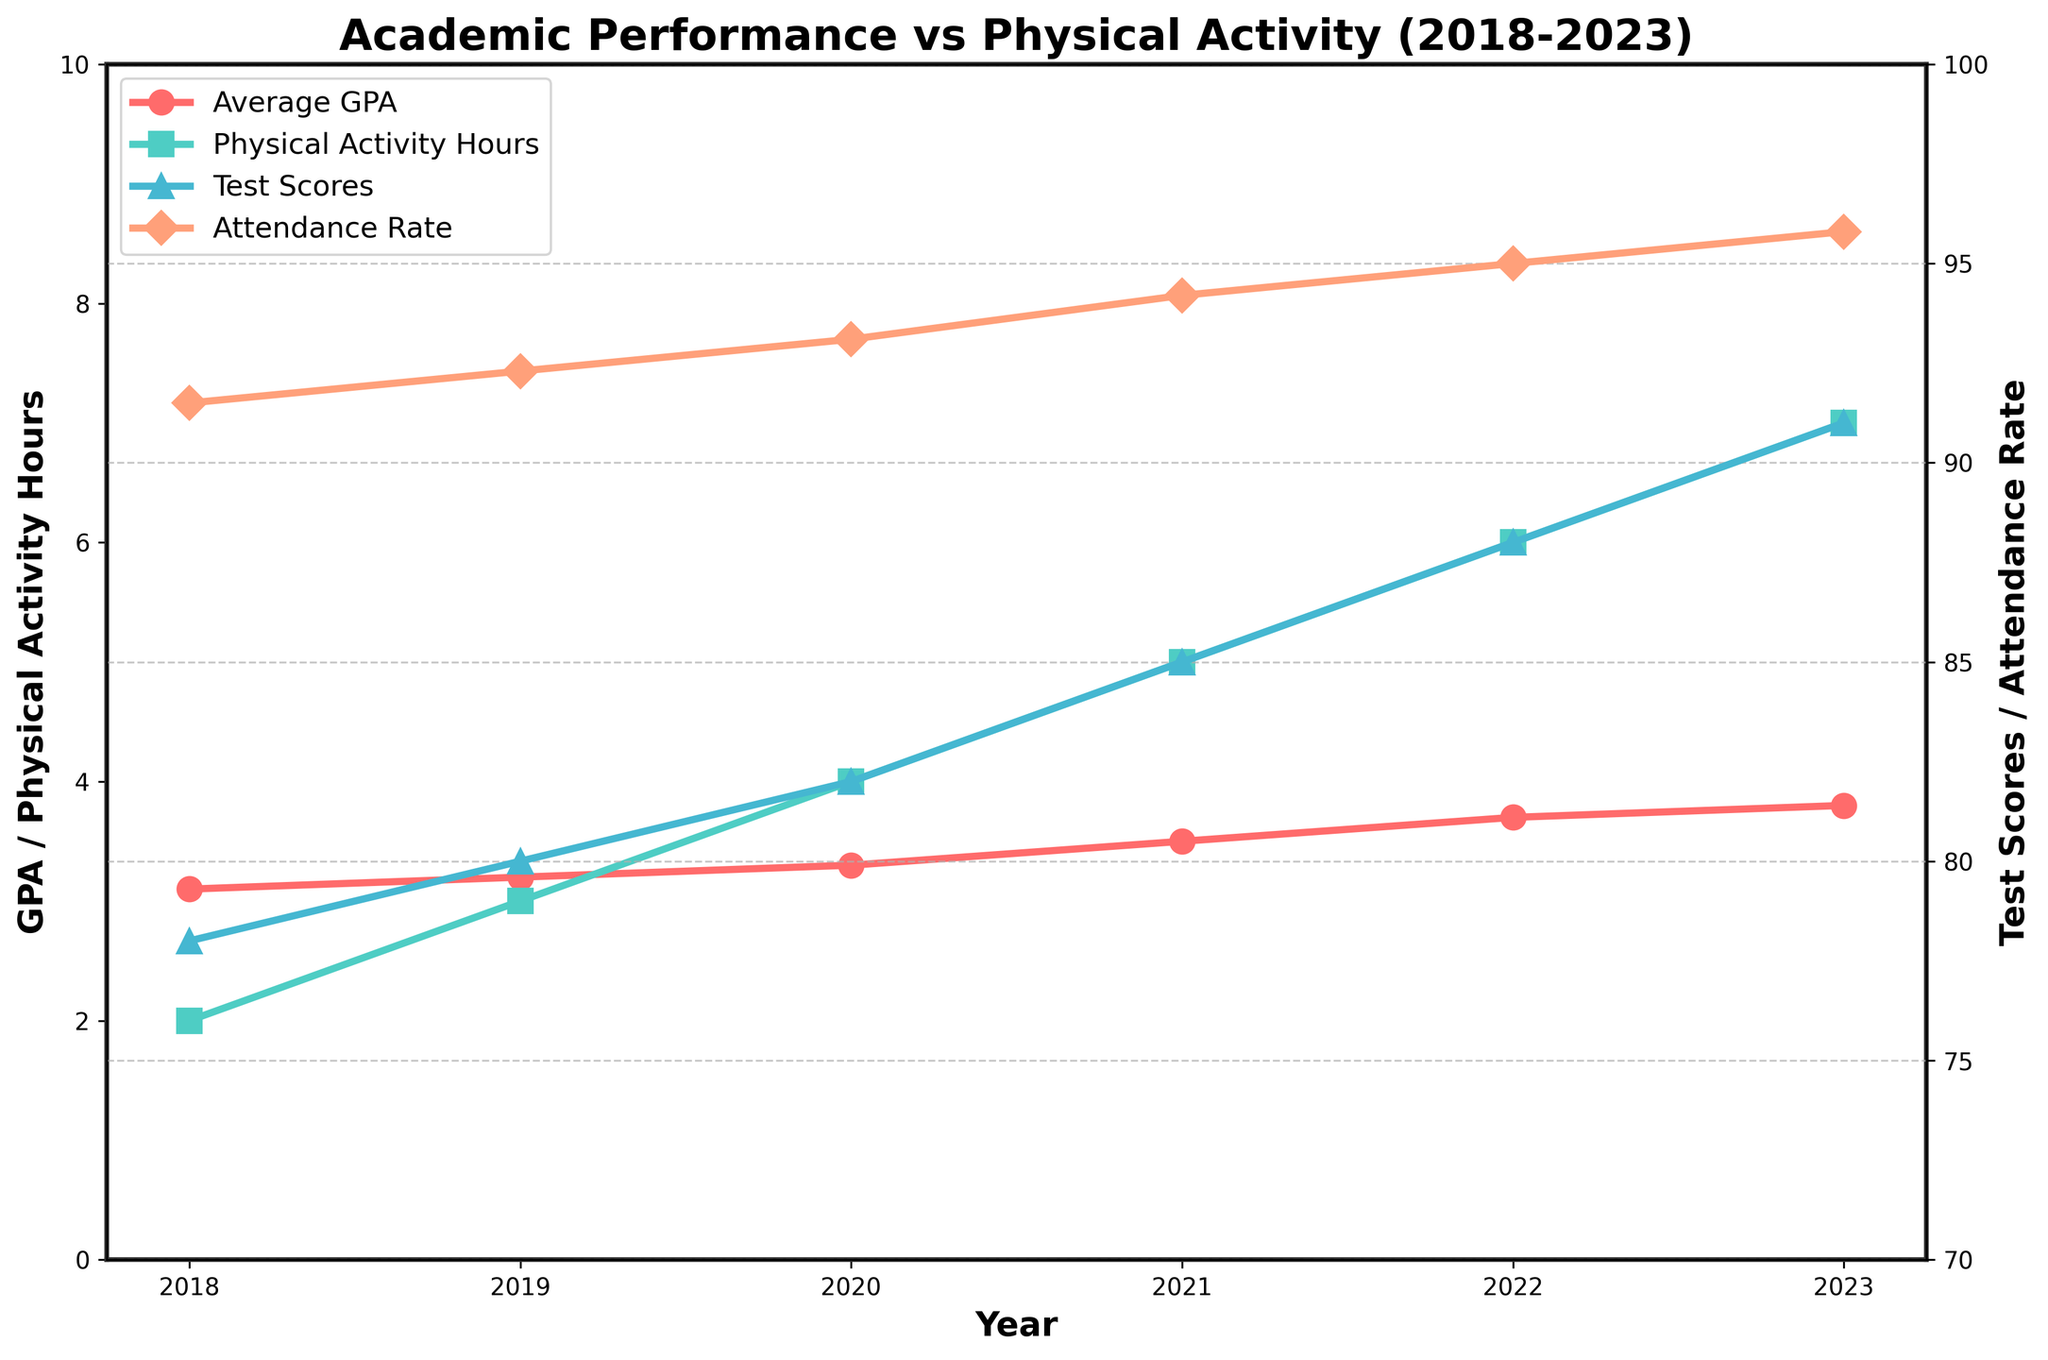What trend do you observe in the Average GPA from 2018 to 2023? Observe the red line with circle markers. It starts at 3.1 in 2018 and increases steadily each year until it reaches 3.8 in 2023.
Answer: It is increasing By how much did the Physical Activity Hours per Week increase from 2018 to 2023? Observe the green line with square markers. In 2018, it is 2 hours per week, and in 2023, it is 7 hours per week. The increase is 7 - 2 = 5 hours.
Answer: 5 hours In which year did the Standardized Test Scores see the largest increase from the previous year? Observe the blue line with triangle markers. Calculate the year-to-year differences: 2018 to 2019 (+2), 2019 to 2020 (+2), 2020 to 2021 (+3), 2021 to 2022 (+3), 2022 to 2023 (+3). The largest increase is 3, which occurred from 2020 to 2021, 2021 to 2022, and 2022 to 2023.
Answer: 2020 to 2021, 2021 to 2022, 2022 to 2023 What is the average Student Attendance Rate over the years 2018 to 2023? Calculate the sum and then the average: (91.5 + 92.3 + 93.1 + 94.2 + 95.0 + 95.8) / 6 = 561.9 / 6 = 93.65.
Answer: 93.65 Did the increase in Physical Activity Hours per Week correlate with an increase in Average GPA? Compare the green line (Physical Activity) with the red line (GPA). Both lines show an upward trend over the years.
Answer: Yes Which year had the highest Standardized Test Scores? Locate the highest point on the blue line with triangle markers. The highest score of 91 is in 2023.
Answer: 2023 In what year did the Student Attendance Rate first surpass 94%? Observe the orange line with diamond markers. In 2021, the attendance rate first goes above 94%.
Answer: 2021 How much did the Average GPA increase from 2019 to 2022? Observe the red line. In 2019, the GPA is 3.2. In 2022, the GPA is 3.7. The increase is 3.7 - 3.2 = 0.5.
Answer: 0.5 How does the visual representation of the Physical Activity Hours per Week compare to that of Standardized Test Scores? The green line representing Physical Activity Hours uses square markers and is plotted on the left y-axis. The blue line representing Standardized Test Scores uses triangle markers and is plotted on the right y-axis. Both lines show increasing trends.
Answer: Increasing trends Which years have a corresponding increase in both Standardized Test Scores and Student Attendance Rate? Compare the blue and orange lines. Both values increase from 2018 each year until 2023.
Answer: 2018-2023 